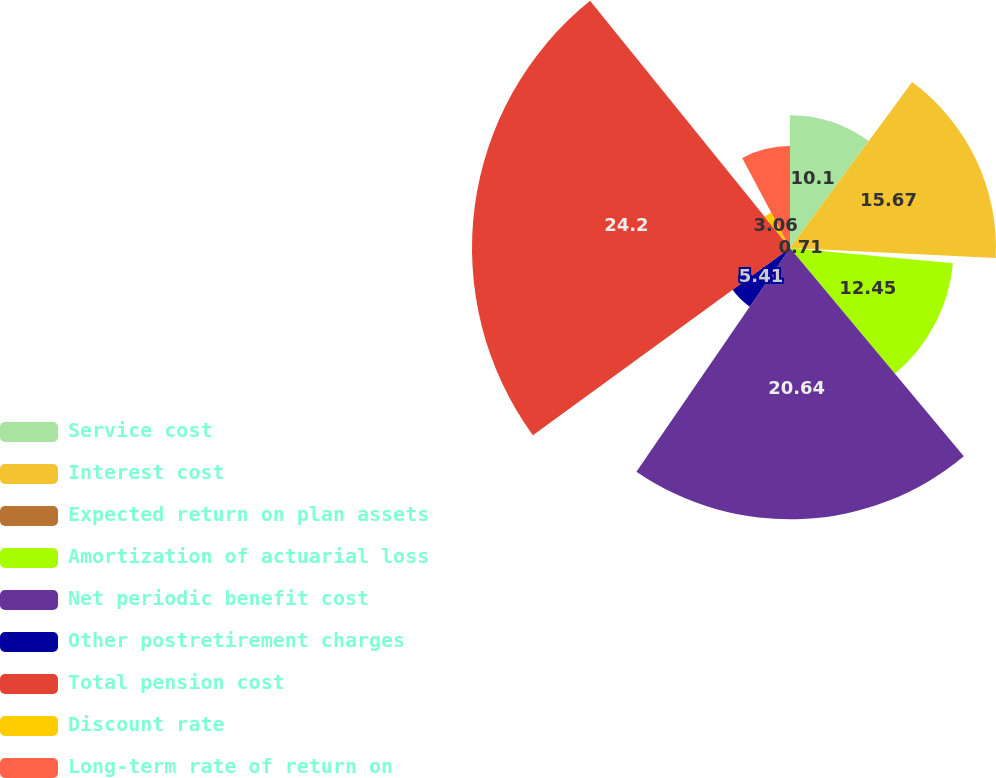<chart> <loc_0><loc_0><loc_500><loc_500><pie_chart><fcel>Service cost<fcel>Interest cost<fcel>Expected return on plan assets<fcel>Amortization of actuarial loss<fcel>Net periodic benefit cost<fcel>Other postretirement charges<fcel>Total pension cost<fcel>Discount rate<fcel>Long-term rate of return on<nl><fcel>10.1%<fcel>15.67%<fcel>0.71%<fcel>12.45%<fcel>20.64%<fcel>5.41%<fcel>24.19%<fcel>3.06%<fcel>7.76%<nl></chart> 